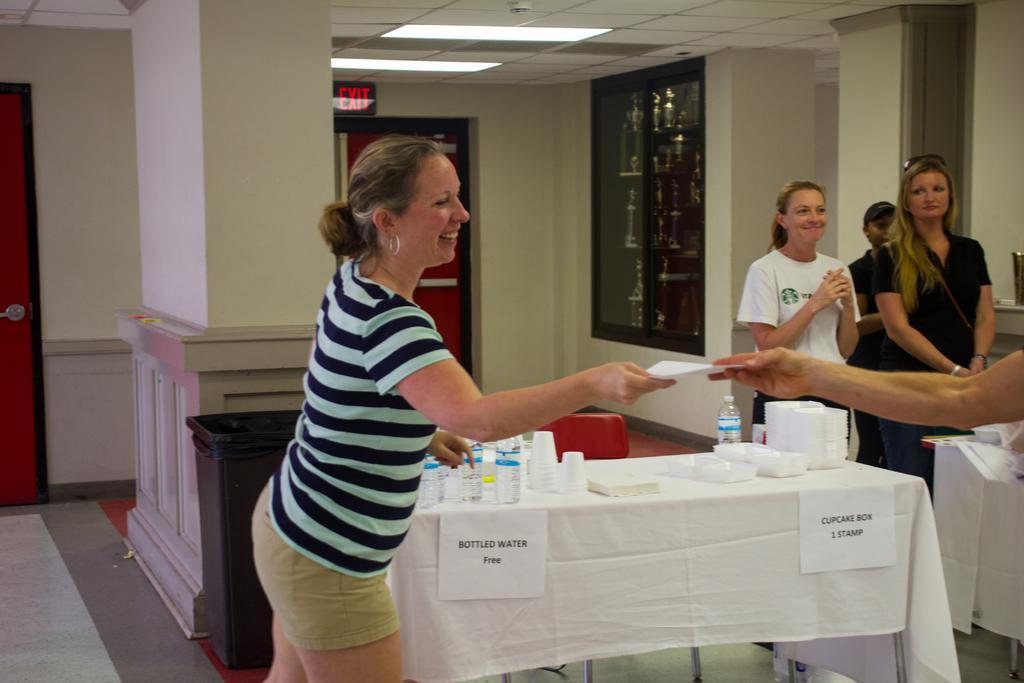Could you give a brief overview of what you see in this image? An indoor picture. This is a rack with things. This is door. This woman's are standing. On a table there are bottles, cups and plates. Beside this table there is a chair. This is bin on floor. This woman is holding a paper. Far a man is standing. 